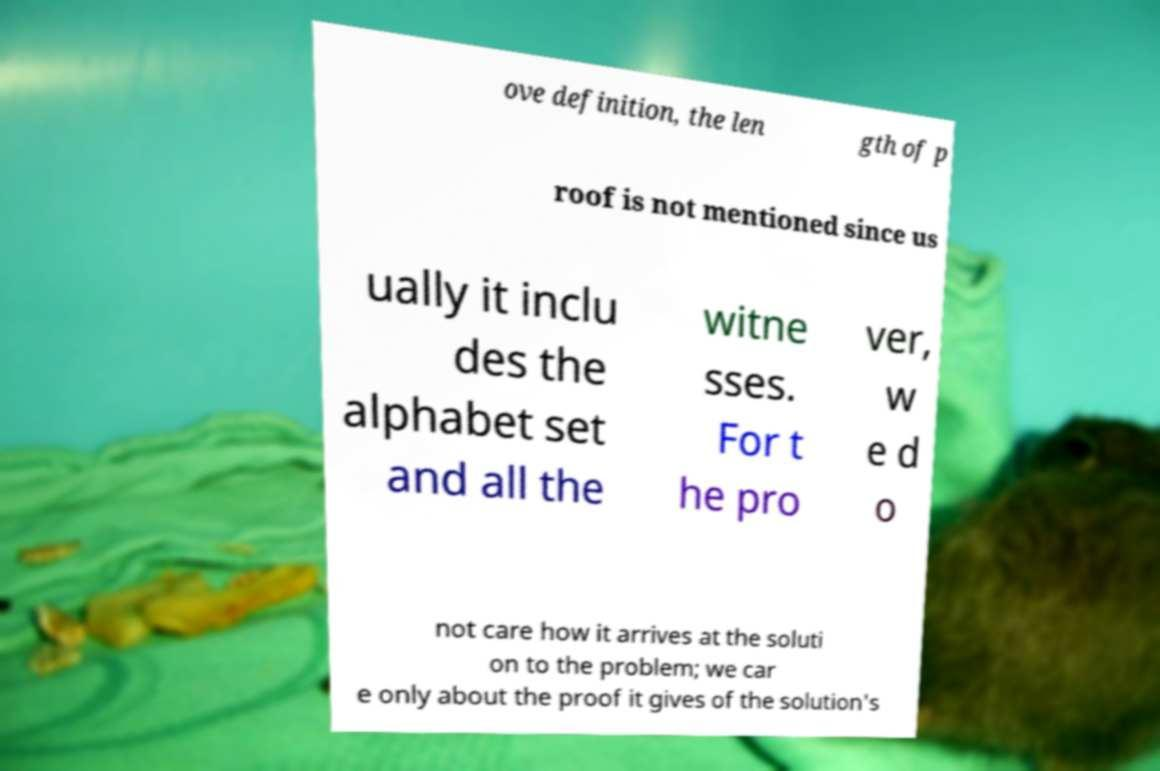Can you accurately transcribe the text from the provided image for me? ove definition, the len gth of p roof is not mentioned since us ually it inclu des the alphabet set and all the witne sses. For t he pro ver, w e d o not care how it arrives at the soluti on to the problem; we car e only about the proof it gives of the solution's 